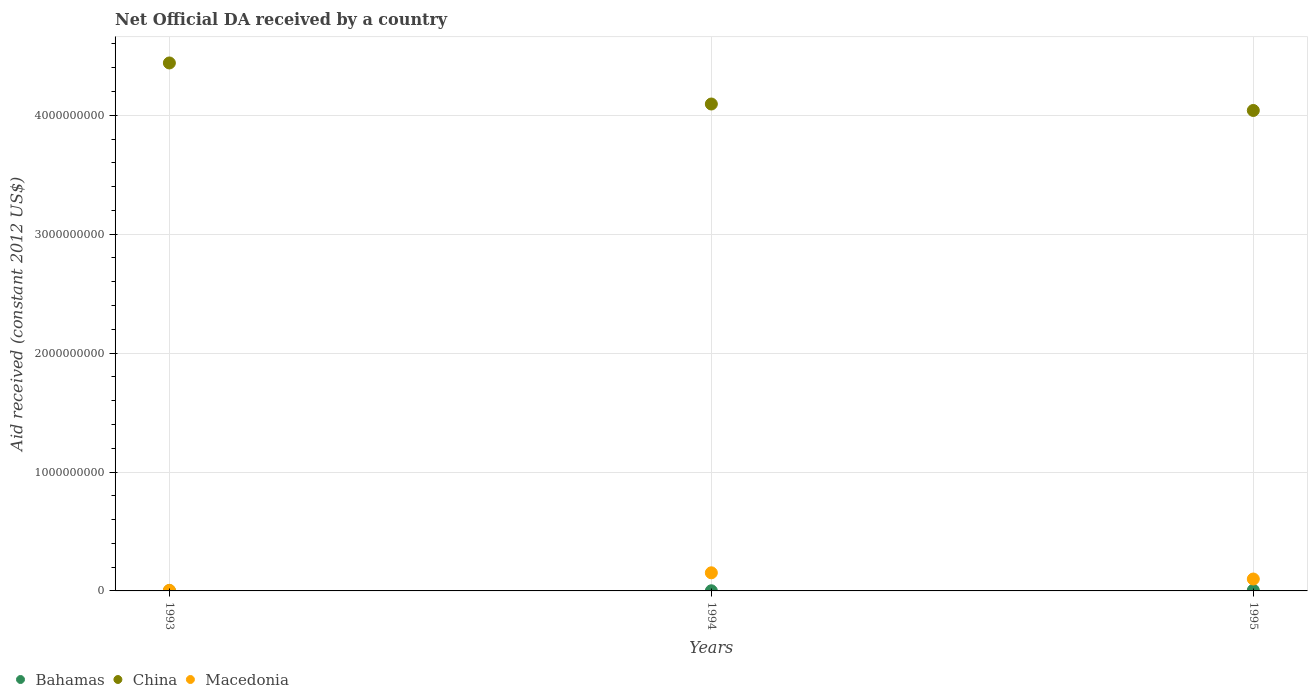How many different coloured dotlines are there?
Keep it short and to the point. 3. What is the net official development assistance aid received in Macedonia in 1993?
Provide a succinct answer. 5.11e+06. Across all years, what is the maximum net official development assistance aid received in Macedonia?
Your answer should be compact. 1.52e+08. Across all years, what is the minimum net official development assistance aid received in Macedonia?
Give a very brief answer. 5.11e+06. What is the total net official development assistance aid received in China in the graph?
Offer a terse response. 1.26e+1. What is the difference between the net official development assistance aid received in Bahamas in 1993 and that in 1995?
Your response must be concise. -4.11e+06. What is the difference between the net official development assistance aid received in China in 1994 and the net official development assistance aid received in Macedonia in 1995?
Make the answer very short. 3.99e+09. What is the average net official development assistance aid received in China per year?
Provide a succinct answer. 4.19e+09. In the year 1993, what is the difference between the net official development assistance aid received in Macedonia and net official development assistance aid received in China?
Your answer should be very brief. -4.43e+09. What is the ratio of the net official development assistance aid received in Macedonia in 1994 to that in 1995?
Offer a very short reply. 1.52. Is the net official development assistance aid received in Bahamas in 1993 less than that in 1994?
Provide a short and direct response. No. What is the difference between the highest and the second highest net official development assistance aid received in Bahamas?
Provide a short and direct response. 4.11e+06. What is the difference between the highest and the lowest net official development assistance aid received in Macedonia?
Ensure brevity in your answer.  1.47e+08. In how many years, is the net official development assistance aid received in Macedonia greater than the average net official development assistance aid received in Macedonia taken over all years?
Your answer should be compact. 2. Is it the case that in every year, the sum of the net official development assistance aid received in Macedonia and net official development assistance aid received in China  is greater than the net official development assistance aid received in Bahamas?
Provide a short and direct response. Yes. Is the net official development assistance aid received in Macedonia strictly less than the net official development assistance aid received in China over the years?
Provide a succinct answer. Yes. How many years are there in the graph?
Offer a very short reply. 3. Where does the legend appear in the graph?
Provide a succinct answer. Bottom left. How many legend labels are there?
Provide a succinct answer. 3. What is the title of the graph?
Your answer should be very brief. Net Official DA received by a country. What is the label or title of the Y-axis?
Offer a very short reply. Aid received (constant 2012 US$). What is the Aid received (constant 2012 US$) in Bahamas in 1993?
Give a very brief answer. 1.56e+06. What is the Aid received (constant 2012 US$) in China in 1993?
Offer a terse response. 4.44e+09. What is the Aid received (constant 2012 US$) of Macedonia in 1993?
Make the answer very short. 5.11e+06. What is the Aid received (constant 2012 US$) of Bahamas in 1994?
Give a very brief answer. 1.26e+06. What is the Aid received (constant 2012 US$) in China in 1994?
Give a very brief answer. 4.09e+09. What is the Aid received (constant 2012 US$) of Macedonia in 1994?
Provide a short and direct response. 1.52e+08. What is the Aid received (constant 2012 US$) in Bahamas in 1995?
Ensure brevity in your answer.  5.67e+06. What is the Aid received (constant 2012 US$) of China in 1995?
Make the answer very short. 4.04e+09. What is the Aid received (constant 2012 US$) in Macedonia in 1995?
Provide a succinct answer. 1.00e+08. Across all years, what is the maximum Aid received (constant 2012 US$) of Bahamas?
Your response must be concise. 5.67e+06. Across all years, what is the maximum Aid received (constant 2012 US$) in China?
Your response must be concise. 4.44e+09. Across all years, what is the maximum Aid received (constant 2012 US$) of Macedonia?
Your response must be concise. 1.52e+08. Across all years, what is the minimum Aid received (constant 2012 US$) of Bahamas?
Make the answer very short. 1.26e+06. Across all years, what is the minimum Aid received (constant 2012 US$) of China?
Ensure brevity in your answer.  4.04e+09. Across all years, what is the minimum Aid received (constant 2012 US$) of Macedonia?
Your answer should be compact. 5.11e+06. What is the total Aid received (constant 2012 US$) of Bahamas in the graph?
Offer a very short reply. 8.49e+06. What is the total Aid received (constant 2012 US$) in China in the graph?
Ensure brevity in your answer.  1.26e+1. What is the total Aid received (constant 2012 US$) of Macedonia in the graph?
Offer a very short reply. 2.58e+08. What is the difference between the Aid received (constant 2012 US$) in China in 1993 and that in 1994?
Ensure brevity in your answer.  3.45e+08. What is the difference between the Aid received (constant 2012 US$) of Macedonia in 1993 and that in 1994?
Offer a terse response. -1.47e+08. What is the difference between the Aid received (constant 2012 US$) in Bahamas in 1993 and that in 1995?
Provide a succinct answer. -4.11e+06. What is the difference between the Aid received (constant 2012 US$) of China in 1993 and that in 1995?
Provide a succinct answer. 3.99e+08. What is the difference between the Aid received (constant 2012 US$) in Macedonia in 1993 and that in 1995?
Offer a very short reply. -9.50e+07. What is the difference between the Aid received (constant 2012 US$) of Bahamas in 1994 and that in 1995?
Make the answer very short. -4.41e+06. What is the difference between the Aid received (constant 2012 US$) of China in 1994 and that in 1995?
Offer a very short reply. 5.43e+07. What is the difference between the Aid received (constant 2012 US$) in Macedonia in 1994 and that in 1995?
Provide a succinct answer. 5.23e+07. What is the difference between the Aid received (constant 2012 US$) of Bahamas in 1993 and the Aid received (constant 2012 US$) of China in 1994?
Make the answer very short. -4.09e+09. What is the difference between the Aid received (constant 2012 US$) of Bahamas in 1993 and the Aid received (constant 2012 US$) of Macedonia in 1994?
Ensure brevity in your answer.  -1.51e+08. What is the difference between the Aid received (constant 2012 US$) in China in 1993 and the Aid received (constant 2012 US$) in Macedonia in 1994?
Provide a short and direct response. 4.29e+09. What is the difference between the Aid received (constant 2012 US$) in Bahamas in 1993 and the Aid received (constant 2012 US$) in China in 1995?
Make the answer very short. -4.04e+09. What is the difference between the Aid received (constant 2012 US$) of Bahamas in 1993 and the Aid received (constant 2012 US$) of Macedonia in 1995?
Provide a short and direct response. -9.86e+07. What is the difference between the Aid received (constant 2012 US$) in China in 1993 and the Aid received (constant 2012 US$) in Macedonia in 1995?
Ensure brevity in your answer.  4.34e+09. What is the difference between the Aid received (constant 2012 US$) of Bahamas in 1994 and the Aid received (constant 2012 US$) of China in 1995?
Your response must be concise. -4.04e+09. What is the difference between the Aid received (constant 2012 US$) of Bahamas in 1994 and the Aid received (constant 2012 US$) of Macedonia in 1995?
Offer a terse response. -9.89e+07. What is the difference between the Aid received (constant 2012 US$) in China in 1994 and the Aid received (constant 2012 US$) in Macedonia in 1995?
Your answer should be very brief. 3.99e+09. What is the average Aid received (constant 2012 US$) of Bahamas per year?
Provide a succinct answer. 2.83e+06. What is the average Aid received (constant 2012 US$) in China per year?
Your answer should be very brief. 4.19e+09. What is the average Aid received (constant 2012 US$) in Macedonia per year?
Your answer should be compact. 8.59e+07. In the year 1993, what is the difference between the Aid received (constant 2012 US$) of Bahamas and Aid received (constant 2012 US$) of China?
Ensure brevity in your answer.  -4.44e+09. In the year 1993, what is the difference between the Aid received (constant 2012 US$) in Bahamas and Aid received (constant 2012 US$) in Macedonia?
Provide a short and direct response. -3.55e+06. In the year 1993, what is the difference between the Aid received (constant 2012 US$) in China and Aid received (constant 2012 US$) in Macedonia?
Make the answer very short. 4.43e+09. In the year 1994, what is the difference between the Aid received (constant 2012 US$) of Bahamas and Aid received (constant 2012 US$) of China?
Your response must be concise. -4.09e+09. In the year 1994, what is the difference between the Aid received (constant 2012 US$) in Bahamas and Aid received (constant 2012 US$) in Macedonia?
Your answer should be compact. -1.51e+08. In the year 1994, what is the difference between the Aid received (constant 2012 US$) in China and Aid received (constant 2012 US$) in Macedonia?
Provide a succinct answer. 3.94e+09. In the year 1995, what is the difference between the Aid received (constant 2012 US$) in Bahamas and Aid received (constant 2012 US$) in China?
Ensure brevity in your answer.  -4.03e+09. In the year 1995, what is the difference between the Aid received (constant 2012 US$) in Bahamas and Aid received (constant 2012 US$) in Macedonia?
Offer a very short reply. -9.44e+07. In the year 1995, what is the difference between the Aid received (constant 2012 US$) in China and Aid received (constant 2012 US$) in Macedonia?
Your answer should be compact. 3.94e+09. What is the ratio of the Aid received (constant 2012 US$) of Bahamas in 1993 to that in 1994?
Give a very brief answer. 1.24. What is the ratio of the Aid received (constant 2012 US$) in China in 1993 to that in 1994?
Give a very brief answer. 1.08. What is the ratio of the Aid received (constant 2012 US$) in Macedonia in 1993 to that in 1994?
Give a very brief answer. 0.03. What is the ratio of the Aid received (constant 2012 US$) in Bahamas in 1993 to that in 1995?
Provide a short and direct response. 0.28. What is the ratio of the Aid received (constant 2012 US$) in China in 1993 to that in 1995?
Give a very brief answer. 1.1. What is the ratio of the Aid received (constant 2012 US$) of Macedonia in 1993 to that in 1995?
Make the answer very short. 0.05. What is the ratio of the Aid received (constant 2012 US$) of Bahamas in 1994 to that in 1995?
Ensure brevity in your answer.  0.22. What is the ratio of the Aid received (constant 2012 US$) in China in 1994 to that in 1995?
Your answer should be very brief. 1.01. What is the ratio of the Aid received (constant 2012 US$) of Macedonia in 1994 to that in 1995?
Keep it short and to the point. 1.52. What is the difference between the highest and the second highest Aid received (constant 2012 US$) of Bahamas?
Your response must be concise. 4.11e+06. What is the difference between the highest and the second highest Aid received (constant 2012 US$) of China?
Keep it short and to the point. 3.45e+08. What is the difference between the highest and the second highest Aid received (constant 2012 US$) in Macedonia?
Your response must be concise. 5.23e+07. What is the difference between the highest and the lowest Aid received (constant 2012 US$) in Bahamas?
Provide a succinct answer. 4.41e+06. What is the difference between the highest and the lowest Aid received (constant 2012 US$) in China?
Make the answer very short. 3.99e+08. What is the difference between the highest and the lowest Aid received (constant 2012 US$) of Macedonia?
Offer a very short reply. 1.47e+08. 